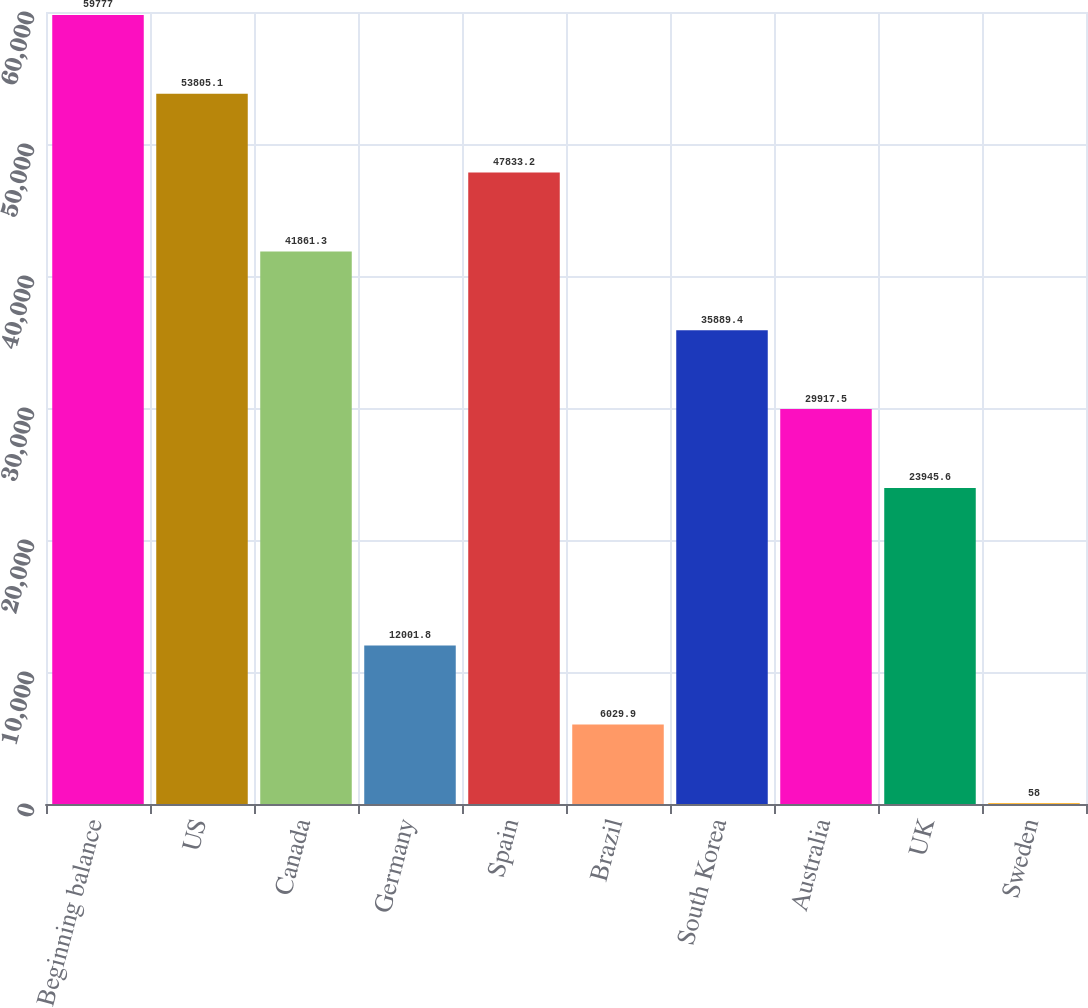Convert chart to OTSL. <chart><loc_0><loc_0><loc_500><loc_500><bar_chart><fcel>Beginning balance<fcel>US<fcel>Canada<fcel>Germany<fcel>Spain<fcel>Brazil<fcel>South Korea<fcel>Australia<fcel>UK<fcel>Sweden<nl><fcel>59777<fcel>53805.1<fcel>41861.3<fcel>12001.8<fcel>47833.2<fcel>6029.9<fcel>35889.4<fcel>29917.5<fcel>23945.6<fcel>58<nl></chart> 